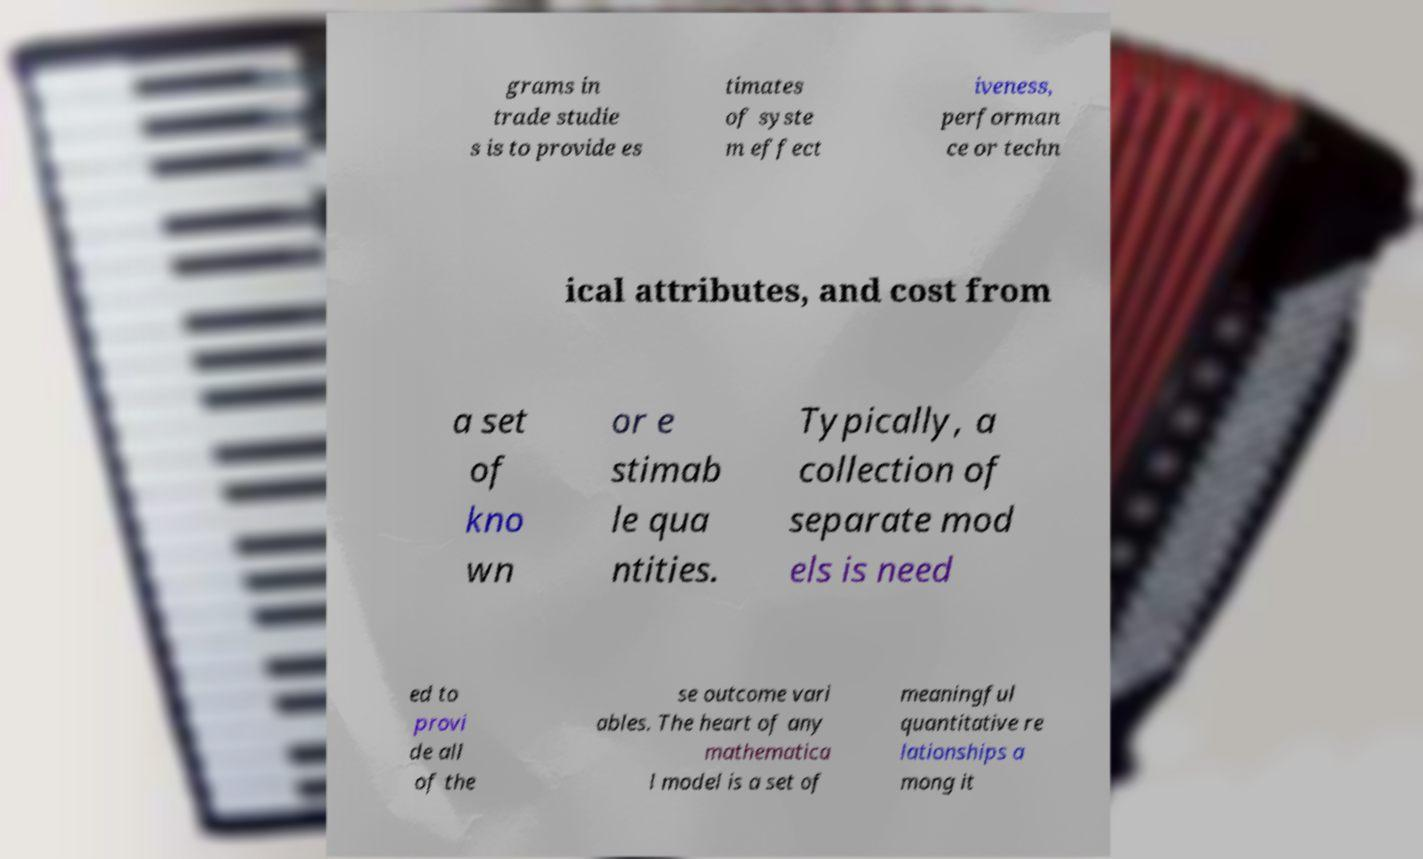For documentation purposes, I need the text within this image transcribed. Could you provide that? grams in trade studie s is to provide es timates of syste m effect iveness, performan ce or techn ical attributes, and cost from a set of kno wn or e stimab le qua ntities. Typically, a collection of separate mod els is need ed to provi de all of the se outcome vari ables. The heart of any mathematica l model is a set of meaningful quantitative re lationships a mong it 